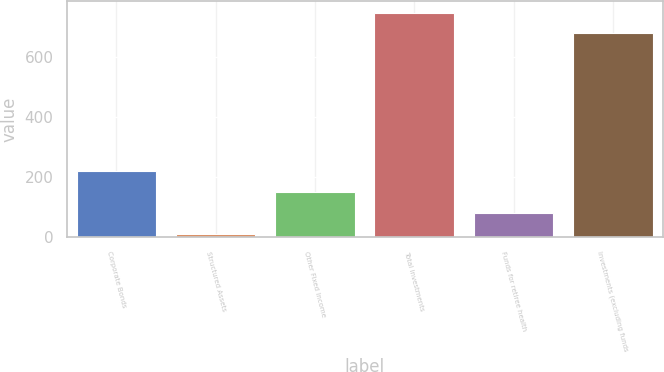Convert chart. <chart><loc_0><loc_0><loc_500><loc_500><bar_chart><fcel>Corporate Bonds<fcel>Structured Assets<fcel>Other Fixed Income<fcel>Total investments<fcel>Funds for retiree health<fcel>Investments (excluding funds<nl><fcel>221.5<fcel>13<fcel>152<fcel>749.5<fcel>82.5<fcel>680<nl></chart> 